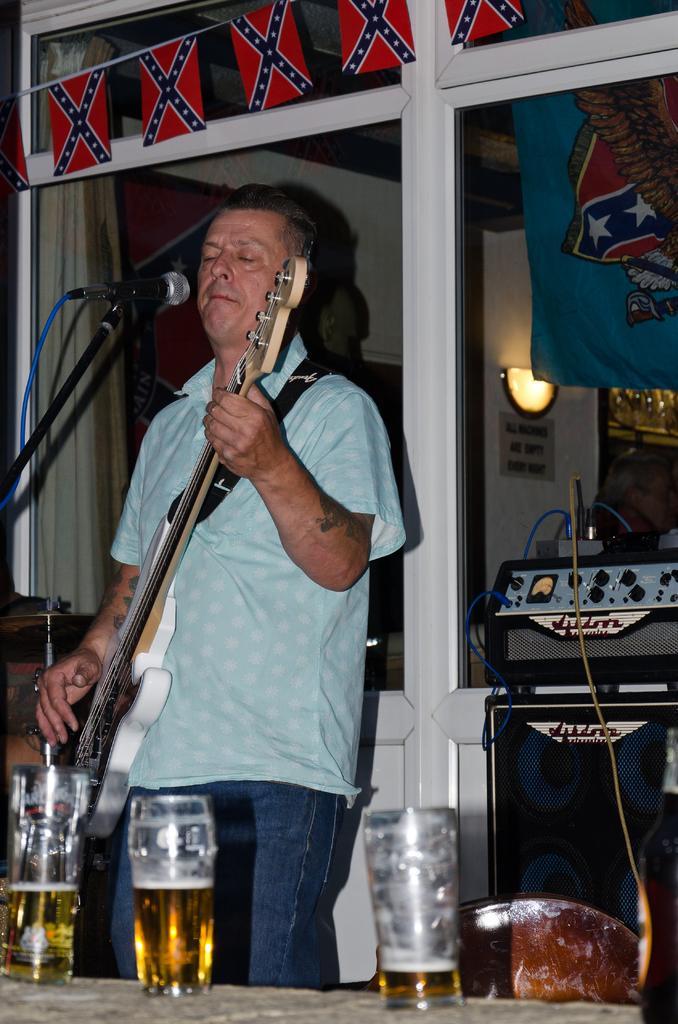Can you describe this image briefly? In this image I can see person holding guitar and he is in front of the mic. I can also see some of the wine glasses on the table. At the back side there is a sound box,banner,light and the board. 